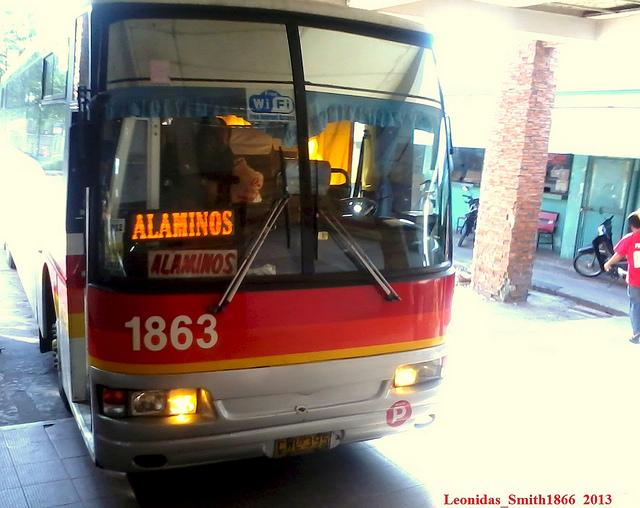What are the metal poles on the window called?

Choices:
A) shuttle sticks
B) handles
C) rackets
D) wipes wipes 